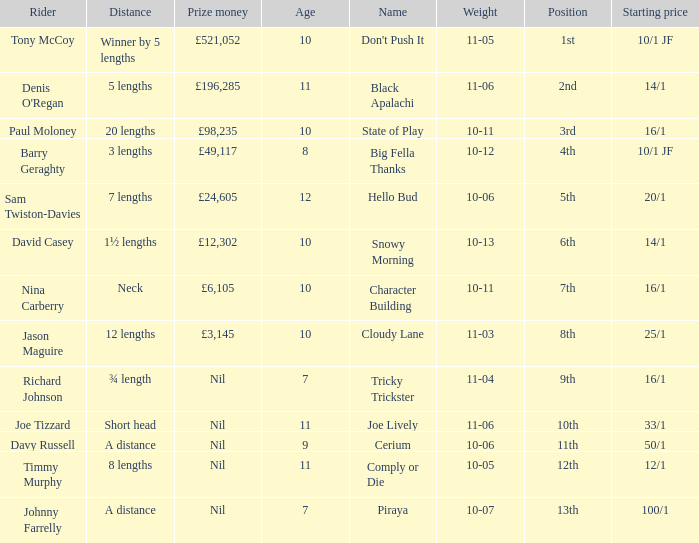 How much did Nina Carberry win?  £6,105. 